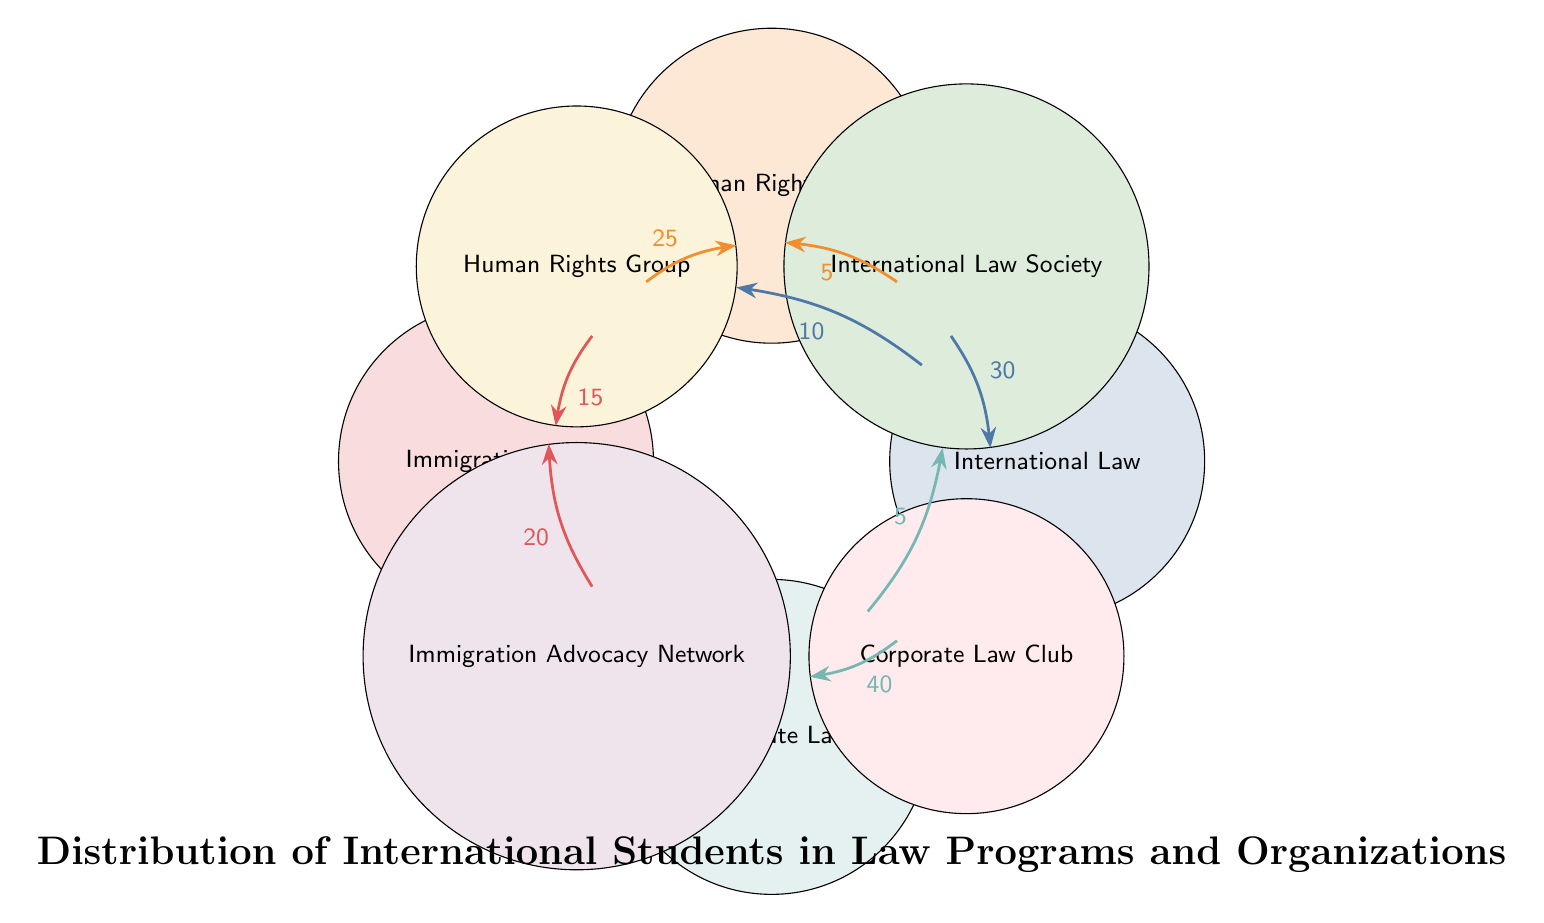What is the total number of students in the Corporate Law program? The diagram shows a connection between the Corporate Law program and the Corporate Law Club with 40 students. Therefore, particularly counting students from other organizations associated with Corporate Law isn't necessary as there are no additional connections shown.
Answer: 40 Which law program has the highest student involvement in organizations? To analyze the student involvement per law program, we look at the connections where students are affiliated with organizations. The Corporate Law program has 40 students in the Corporate Law Club, which is the highest number recorded among all programs.
Answer: Corporate Law How many students from the Immigration Law program are involved in the Human Rights Group? Referring to the connection between Immigration Law and the Human Rights Group, the data indicates that 15 students are involved in this organization from the Immigration Law program.
Answer: 15 Which organization has the greatest number of students from the International Law program? The International Law program has connections with two organizations: the International Law Society with 30 students and the Human Rights Group with 10 students. Since 30 is greater than 10, the International Law Society has the most students from the International Law program.
Answer: International Law Society How many total students are involved in the Immigration Advocacy Network? The Immigration Law program has a direct connection to the Immigration Advocacy Network, indicating that there are 20 students involved in this organization. No other programs connect to it, making this the total.
Answer: 20 Which law program has the least number of students involved in organizations? By examining the connections, we note that the International Law program shows a total of 10 students involved in the Human Rights Group, while the Immigration Law also connects with 15 in the Human Rights Group. The program with the least connections is the Human Rights Law, with just 5 students in the International Law Society, making it the program with the least involvement overall.
Answer: Human Rights Law What is the total number of students involved in the Human Rights Group? The Human Rights Group connects with both the Human Rights Law (25 students) and the Immigration Law (15 students). By adding these two numbers together (25 + 15), we find the total number of involved students to be 40.
Answer: 40 Which organization has the least student involvement overall? From the connections, we see the smallest number associated is the International Law Society with the Corporate Law program, having only 5 students involved from this program. No other connections show a smaller count.
Answer: International Law Society How many law programs are represented in the diagram? The diagram illustrates a total of four distinct law programs: International Law, Human Rights Law, Immigration Law, and Corporate Law. Counting each provides the total representation within the student organization context.
Answer: 4 